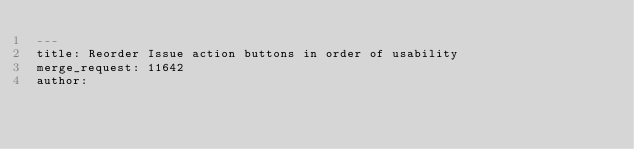Convert code to text. <code><loc_0><loc_0><loc_500><loc_500><_YAML_>---
title: Reorder Issue action buttons in order of usability
merge_request: 11642
author:
</code> 